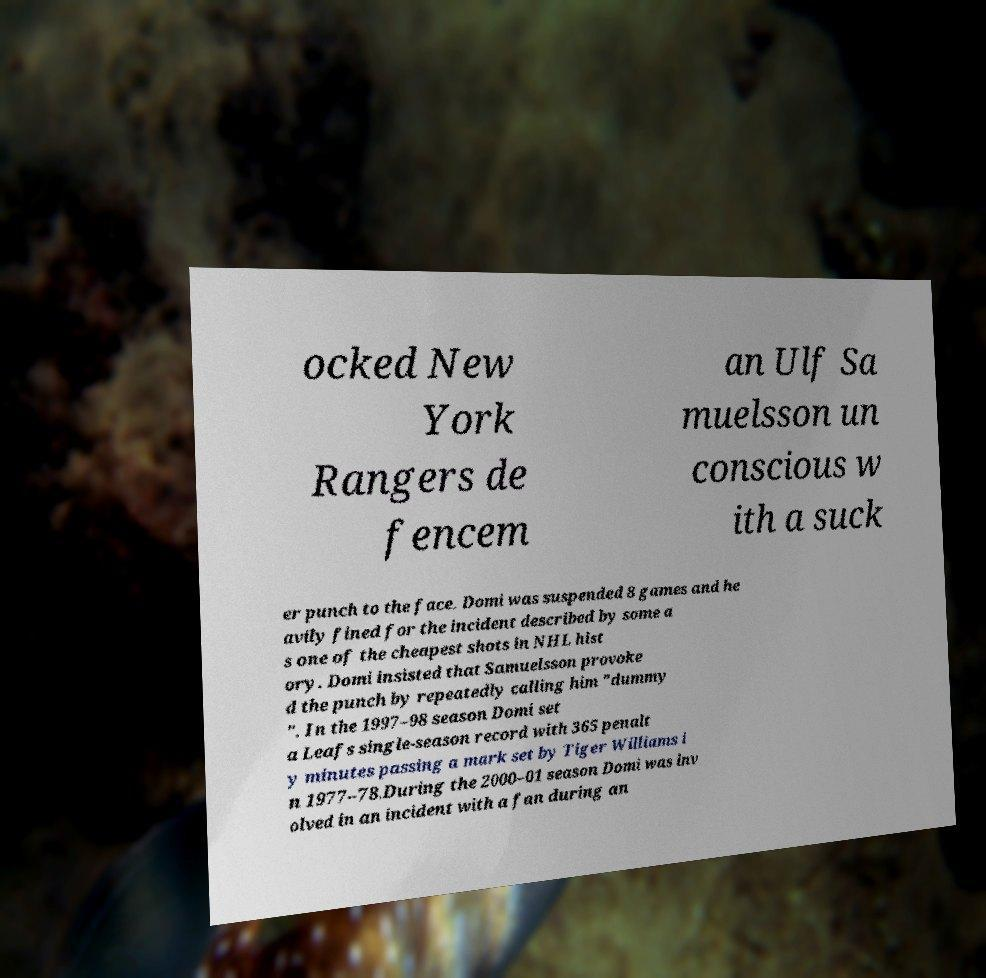For documentation purposes, I need the text within this image transcribed. Could you provide that? ocked New York Rangers de fencem an Ulf Sa muelsson un conscious w ith a suck er punch to the face. Domi was suspended 8 games and he avily fined for the incident described by some a s one of the cheapest shots in NHL hist ory. Domi insisted that Samuelsson provoke d the punch by repeatedly calling him "dummy ". In the 1997–98 season Domi set a Leafs single-season record with 365 penalt y minutes passing a mark set by Tiger Williams i n 1977–78.During the 2000–01 season Domi was inv olved in an incident with a fan during an 